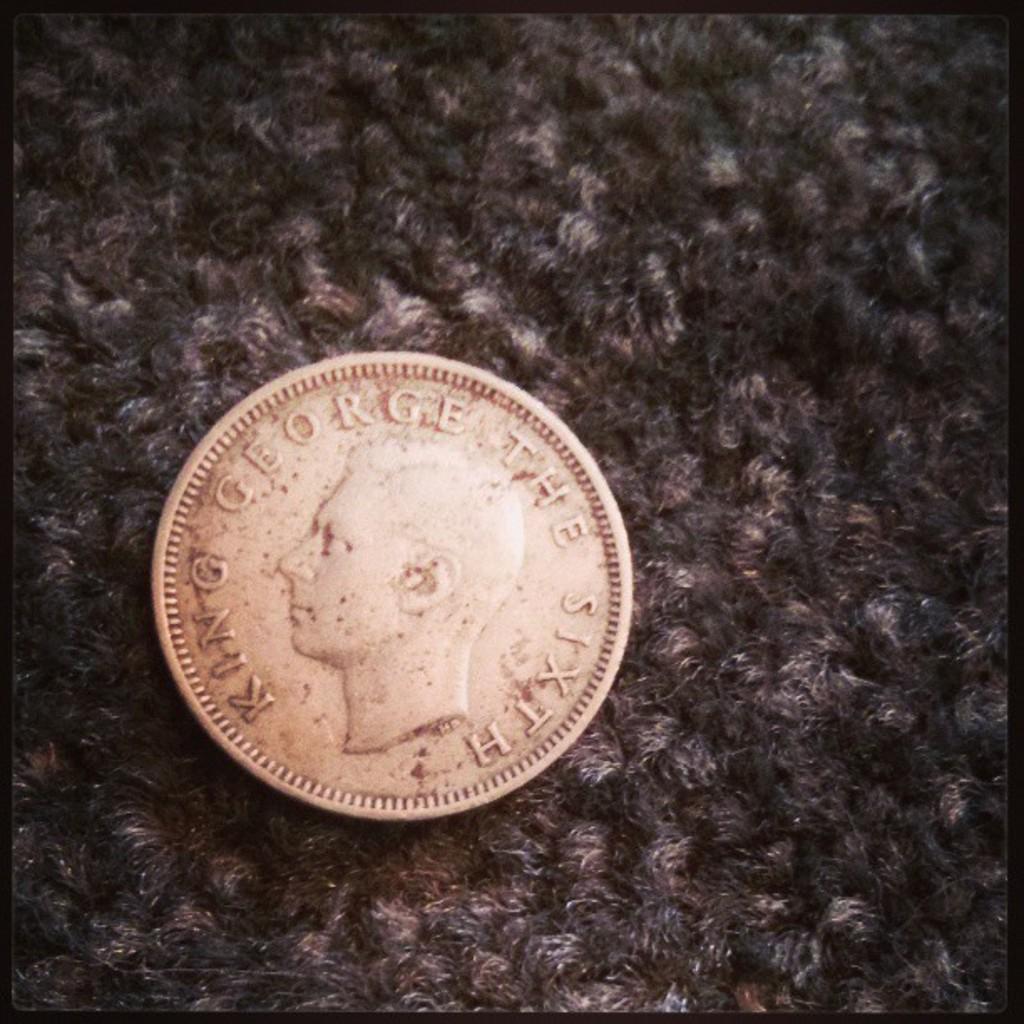Which king is on the coin?
Offer a very short reply. George the sixth. Which number of king george is this?
Ensure brevity in your answer.  Sixth. 